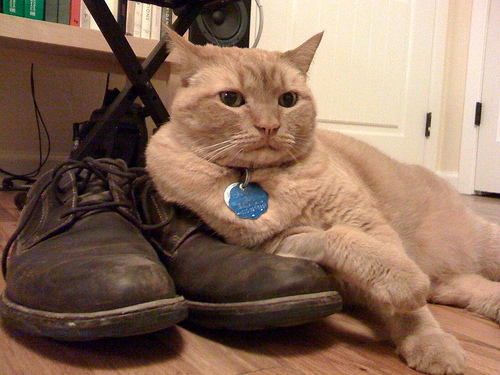<image>What is the brand of shoe? I am not sure about the brand of the shoe. It could be 'doc martens', 'frye', 'dockers', 'dr martin', 'ben davis', or 'oxford'. What is the brand of shoe? I am not sure the brand of the shoe. It can be either 'doc martens', 'frye', 'dockers', 'dr martin', 'ben davis', 'oxford' or unknown. 